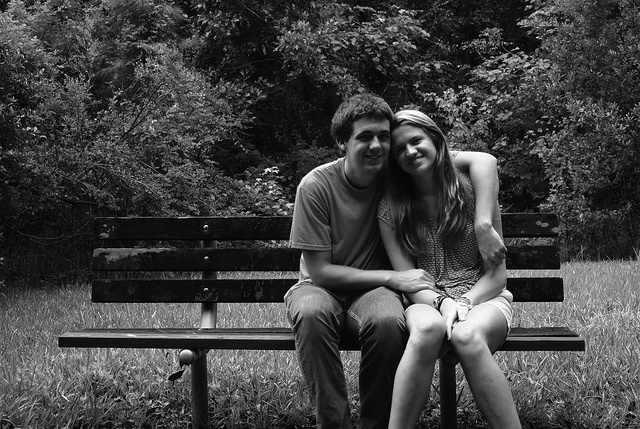Describe the objects in this image and their specific colors. I can see bench in black, gray, darkgray, and lightgray tones, people in black, gray, darkgray, and lightgray tones, and people in black, gray, darkgray, and lightgray tones in this image. 